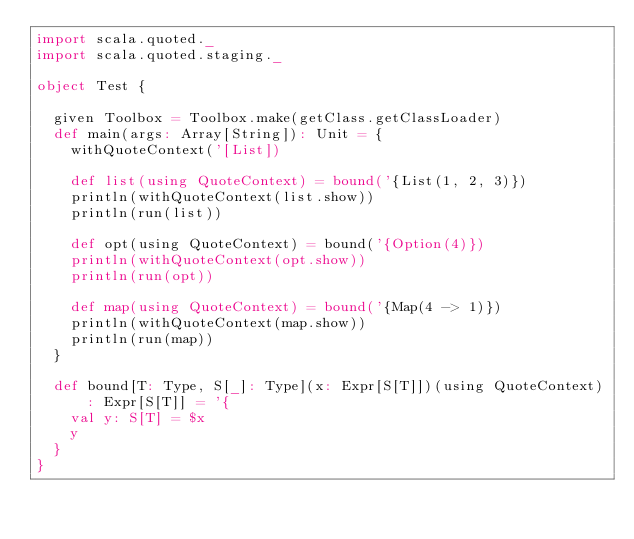<code> <loc_0><loc_0><loc_500><loc_500><_Scala_>import scala.quoted._
import scala.quoted.staging._

object Test {

  given Toolbox = Toolbox.make(getClass.getClassLoader)
  def main(args: Array[String]): Unit = {
    withQuoteContext('[List])

    def list(using QuoteContext) = bound('{List(1, 2, 3)})
    println(withQuoteContext(list.show))
    println(run(list))

    def opt(using QuoteContext) = bound('{Option(4)})
    println(withQuoteContext(opt.show))
    println(run(opt))

    def map(using QuoteContext) = bound('{Map(4 -> 1)})
    println(withQuoteContext(map.show))
    println(run(map))
  }

  def bound[T: Type, S[_]: Type](x: Expr[S[T]])(using QuoteContext): Expr[S[T]] = '{
    val y: S[T] = $x
    y
  }
}
</code> 